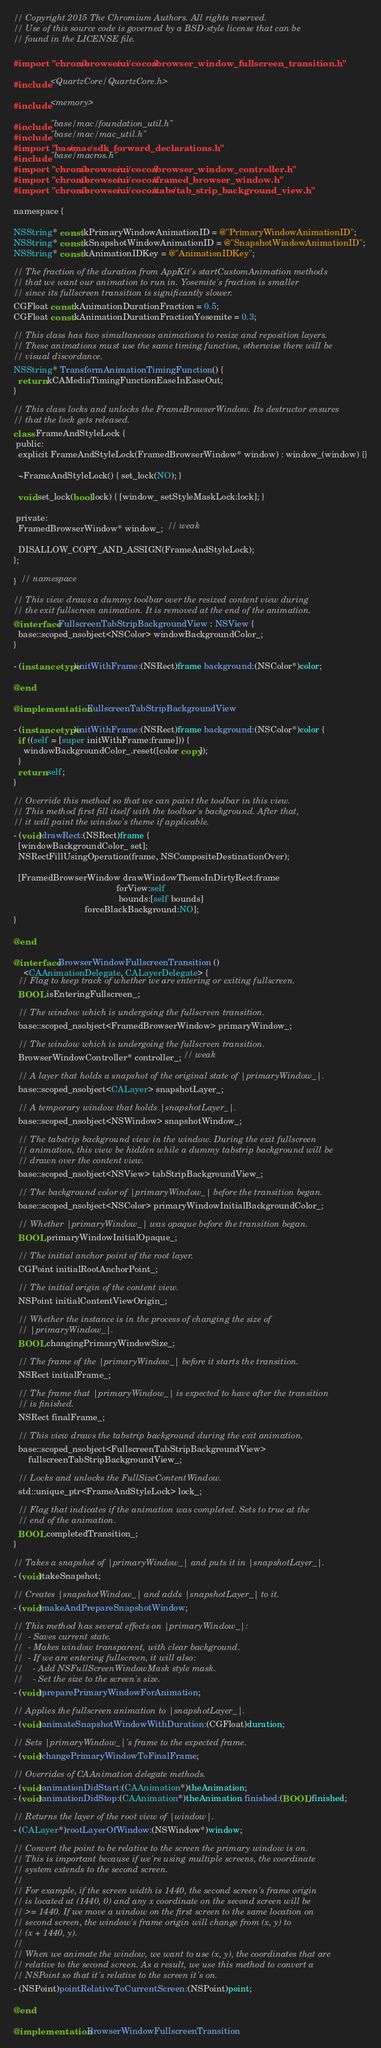<code> <loc_0><loc_0><loc_500><loc_500><_ObjectiveC_>// Copyright 2015 The Chromium Authors. All rights reserved.
// Use of this source code is governed by a BSD-style license that can be
// found in the LICENSE file.

#import "chrome/browser/ui/cocoa/browser_window_fullscreen_transition.h"

#include <QuartzCore/QuartzCore.h>

#include <memory>

#include "base/mac/foundation_util.h"
#include "base/mac/mac_util.h"
#import "base/mac/sdk_forward_declarations.h"
#include "base/macros.h"
#import "chrome/browser/ui/cocoa/browser_window_controller.h"
#import "chrome/browser/ui/cocoa/framed_browser_window.h"
#import "chrome/browser/ui/cocoa/tabs/tab_strip_background_view.h"

namespace {

NSString* const kPrimaryWindowAnimationID = @"PrimaryWindowAnimationID";
NSString* const kSnapshotWindowAnimationID = @"SnapshotWindowAnimationID";
NSString* const kAnimationIDKey = @"AnimationIDKey";

// The fraction of the duration from AppKit's startCustomAnimation methods
// that we want our animation to run in. Yosemite's fraction is smaller
// since its fullscreen transition is significantly slower.
CGFloat const kAnimationDurationFraction = 0.5;
CGFloat const kAnimationDurationFractionYosemite = 0.3;

// This class has two simultaneous animations to resize and reposition layers.
// These animations must use the same timing function, otherwise there will be
// visual discordance.
NSString* TransformAnimationTimingFunction() {
  return kCAMediaTimingFunctionEaseInEaseOut;
}

// This class locks and unlocks the FrameBrowserWindow. Its destructor ensures
// that the lock gets released.
class FrameAndStyleLock {
 public:
  explicit FrameAndStyleLock(FramedBrowserWindow* window) : window_(window) {}

  ~FrameAndStyleLock() { set_lock(NO); }

  void set_lock(bool lock) { [window_ setStyleMaskLock:lock]; }

 private:
  FramedBrowserWindow* window_;  // weak

  DISALLOW_COPY_AND_ASSIGN(FrameAndStyleLock);
};

}  // namespace

// This view draws a dummy toolbar over the resized content view during
// the exit fullscreen animation. It is removed at the end of the animation.
@interface FullscreenTabStripBackgroundView : NSView {
  base::scoped_nsobject<NSColor> windowBackgroundColor_;
}

- (instancetype)initWithFrame:(NSRect)frame background:(NSColor*)color;

@end

@implementation FullscreenTabStripBackgroundView

- (instancetype)initWithFrame:(NSRect)frame background:(NSColor*)color {
  if ((self = [super initWithFrame:frame])) {
    windowBackgroundColor_.reset([color copy]);
  }
  return self;
}

// Override this method so that we can paint the toolbar in this view.
// This method first fill itself with the toolbar's background. After that,
// it will paint the window's theme if applicable.
- (void)drawRect:(NSRect)frame {
  [windowBackgroundColor_ set];
  NSRectFillUsingOperation(frame, NSCompositeDestinationOver);

  [FramedBrowserWindow drawWindowThemeInDirtyRect:frame
                                          forView:self
                                           bounds:[self bounds]
                             forceBlackBackground:NO];
}

@end

@interface BrowserWindowFullscreenTransition ()
    <CAAnimationDelegate, CALayerDelegate> {
  // Flag to keep track of whether we are entering or exiting fullscreen.
  BOOL isEnteringFullscreen_;

  // The window which is undergoing the fullscreen transition.
  base::scoped_nsobject<FramedBrowserWindow> primaryWindow_;

  // The window which is undergoing the fullscreen transition.
  BrowserWindowController* controller_; // weak

  // A layer that holds a snapshot of the original state of |primaryWindow_|.
  base::scoped_nsobject<CALayer> snapshotLayer_;

  // A temporary window that holds |snapshotLayer_|.
  base::scoped_nsobject<NSWindow> snapshotWindow_;

  // The tabstrip background view in the window. During the exit fullscreen
  // animation, this view be hidden while a dummy tabstrip background will be
  // drawn over the content view.
  base::scoped_nsobject<NSView> tabStripBackgroundView_;

  // The background color of |primaryWindow_| before the transition began.
  base::scoped_nsobject<NSColor> primaryWindowInitialBackgroundColor_;

  // Whether |primaryWindow_| was opaque before the transition began.
  BOOL primaryWindowInitialOpaque_;

  // The initial anchor point of the root layer.
  CGPoint initialRootAnchorPoint_;

  // The initial origin of the content view.
  NSPoint initialContentViewOrigin_;

  // Whether the instance is in the process of changing the size of
  // |primaryWindow_|.
  BOOL changingPrimaryWindowSize_;

  // The frame of the |primaryWindow_| before it starts the transition.
  NSRect initialFrame_;

  // The frame that |primaryWindow_| is expected to have after the transition
  // is finished.
  NSRect finalFrame_;

  // This view draws the tabstrip background during the exit animation.
  base::scoped_nsobject<FullscreenTabStripBackgroundView>
      fullscreenTabStripBackgroundView_;

  // Locks and unlocks the FullSizeContentWindow.
  std::unique_ptr<FrameAndStyleLock> lock_;

  // Flag that indicates if the animation was completed. Sets to true at the
  // end of the animation.
  BOOL completedTransition_;
}

// Takes a snapshot of |primaryWindow_| and puts it in |snapshotLayer_|.
- (void)takeSnapshot;

// Creates |snapshotWindow_| and adds |snapshotLayer_| to it.
- (void)makeAndPrepareSnapshotWindow;

// This method has several effects on |primaryWindow_|:
//  - Saves current state.
//  - Makes window transparent, with clear background.
//  - If we are entering fullscreen, it will also:
//    - Add NSFullScreenWindowMask style mask.
//    - Set the size to the screen's size.
- (void)preparePrimaryWindowForAnimation;

// Applies the fullscreen animation to |snapshotLayer_|.
- (void)animateSnapshotWindowWithDuration:(CGFloat)duration;

// Sets |primaryWindow_|'s frame to the expected frame.
- (void)changePrimaryWindowToFinalFrame;

// Overrides of CAAnimation delegate methods.
- (void)animationDidStart:(CAAnimation*)theAnimation;
- (void)animationDidStop:(CAAnimation*)theAnimation finished:(BOOL)finished;

// Returns the layer of the root view of |window|.
- (CALayer*)rootLayerOfWindow:(NSWindow*)window;

// Convert the point to be relative to the screen the primary window is on.
// This is important because if we're using multiple screens, the coordinate
// system extends to the second screen.
//
// For example, if the screen width is 1440, the second screen's frame origin
// is located at (1440, 0) and any x coordinate on the second screen will be
// >= 1440. If we move a window on the first screen to the same location on
// second screen, the window's frame origin will change from (x, y) to
// (x + 1440, y).
//
// When we animate the window, we want to use (x, y), the coordinates that are
// relative to the second screen. As a result, we use this method to convert a
// NSPoint so that it's relative to the screen it's on.
- (NSPoint)pointRelativeToCurrentScreen:(NSPoint)point;

@end

@implementation BrowserWindowFullscreenTransition
</code> 